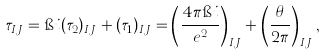<formula> <loc_0><loc_0><loc_500><loc_500>\tau _ { I J } = \i i ( \tau _ { 2 } ) _ { I J } + ( \tau _ { 1 } ) _ { I J } = \left ( \frac { 4 \pi \i i } { e ^ { 2 } } \right ) _ { I J } + \left ( \frac { \theta } { 2 \pi } \right ) _ { I J } ,</formula> 